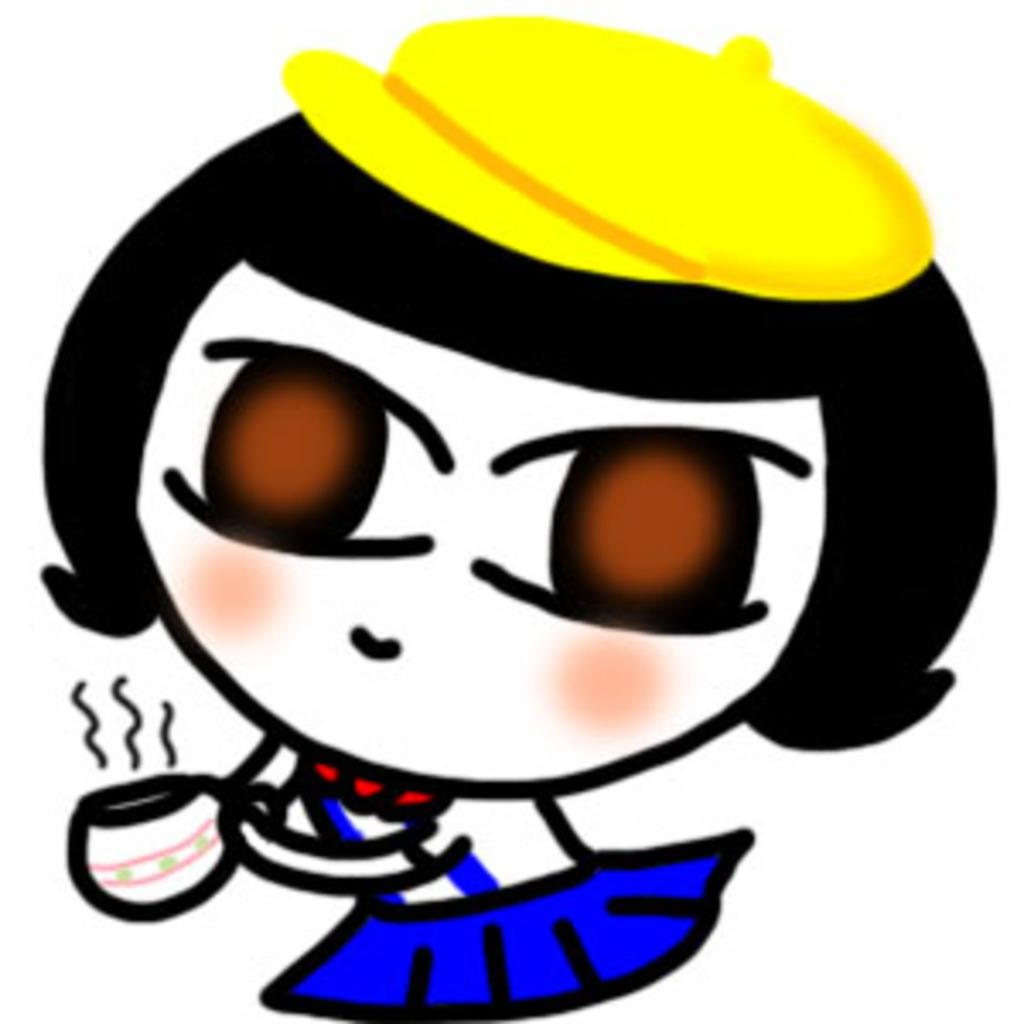What is the main subject of the image? There is a cartoon girl in the image. What is the girl holding in the image? The girl is holding a cup. What color is the dress the girl is wearing? The girl is wearing a blue dress. What type of headwear is the girl wearing? The girl is wearing a yellow cap. What type of map is the girl holding in the image? There is no map present in the image; the girl is holding a cup. Can you tell me how fast the girl is running in the image? The girl is not running in the image; she is standing still while holding a cup. 